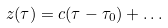<formula> <loc_0><loc_0><loc_500><loc_500>z ( \tau ) = c ( \tau - \tau _ { 0 } ) + \dots</formula> 